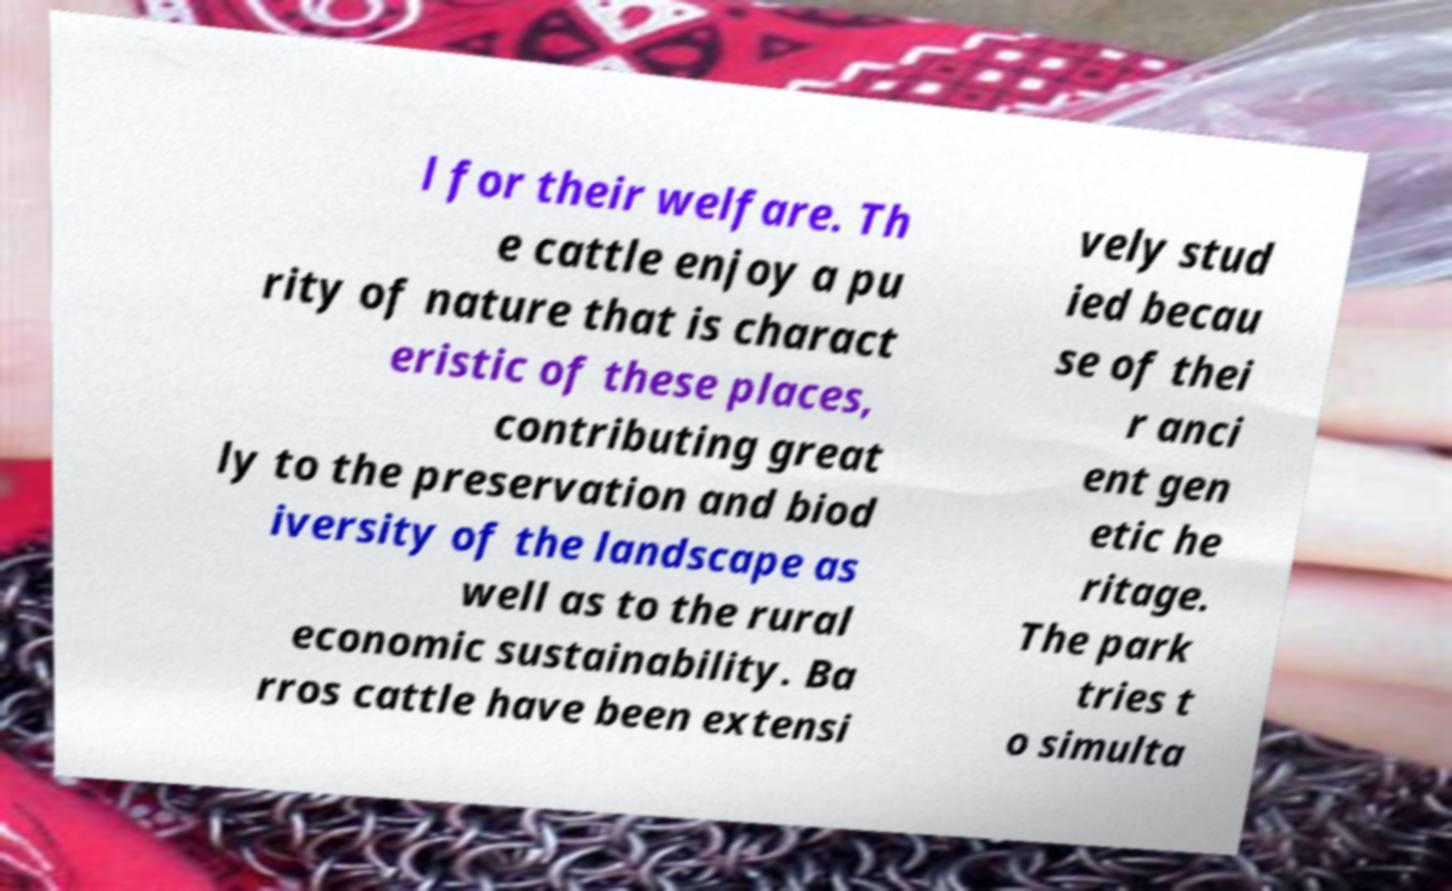Could you extract and type out the text from this image? l for their welfare. Th e cattle enjoy a pu rity of nature that is charact eristic of these places, contributing great ly to the preservation and biod iversity of the landscape as well as to the rural economic sustainability. Ba rros cattle have been extensi vely stud ied becau se of thei r anci ent gen etic he ritage. The park tries t o simulta 